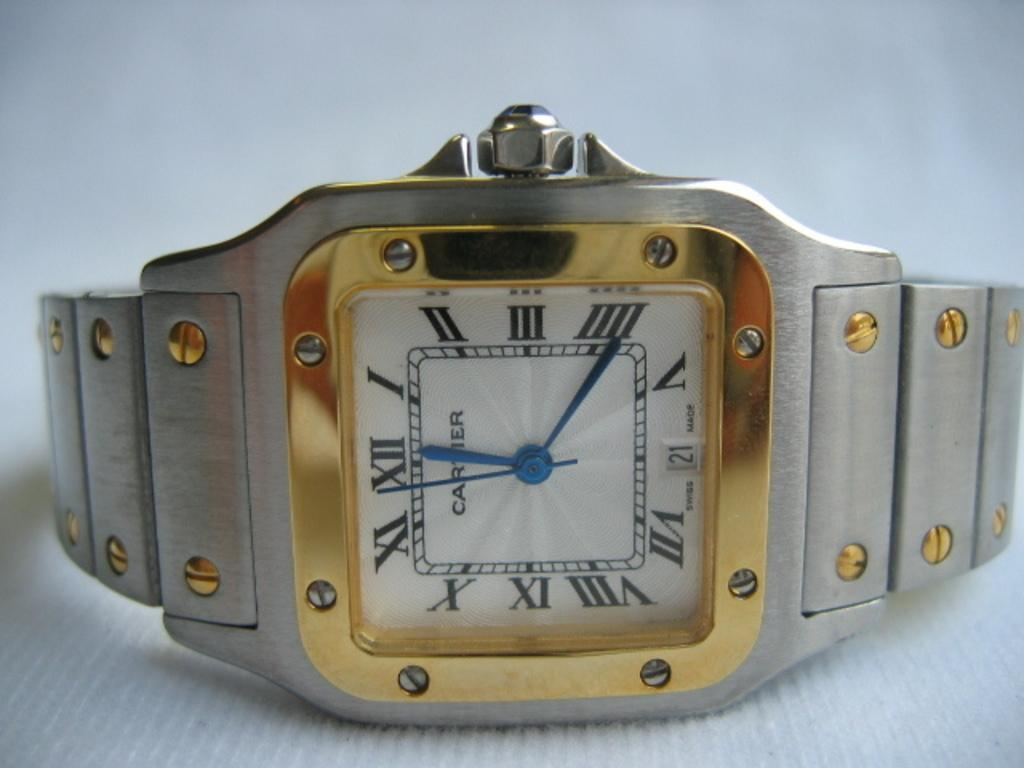<image>
Give a short and clear explanation of the subsequent image. A silver and gold Cartier watch sits against a white surface 